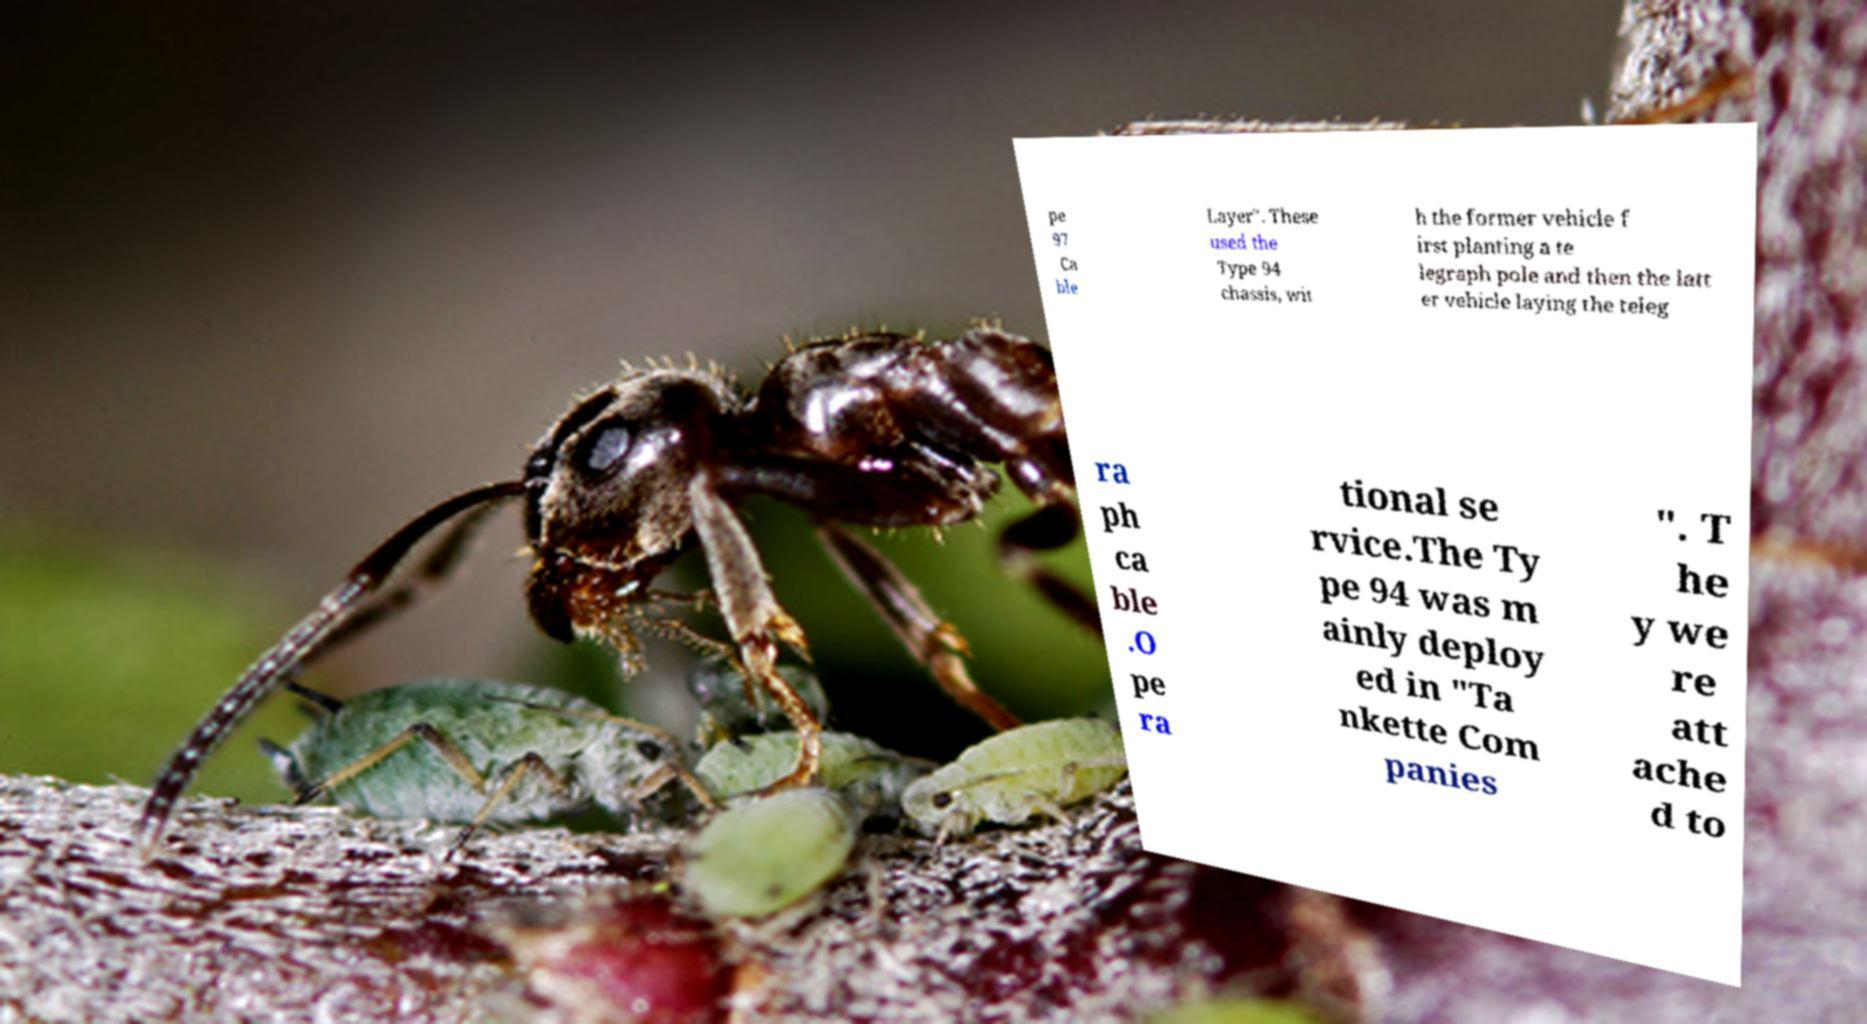Can you accurately transcribe the text from the provided image for me? pe 97 Ca ble Layer". These used the Type 94 chassis, wit h the former vehicle f irst planting a te legraph pole and then the latt er vehicle laying the teleg ra ph ca ble .O pe ra tional se rvice.The Ty pe 94 was m ainly deploy ed in "Ta nkette Com panies ". T he y we re att ache d to 